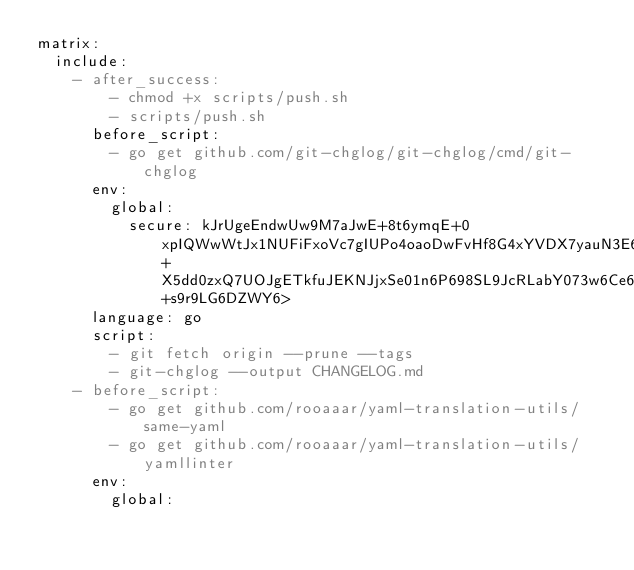<code> <loc_0><loc_0><loc_500><loc_500><_YAML_>matrix:
  include:
    - after_success:
        - chmod +x scripts/push.sh
        - scripts/push.sh
      before_script:
        - go get github.com/git-chglog/git-chglog/cmd/git-chglog
      env:
        global:
          secure: kJrUgeEndwUw9M7aJwE+8t6ymqE+0xpIQWwWtJx1NUFiFxoVc7gIUPo4oaoDwFvHf8G4xYVDX7yauN3E6TDFX7NRjcFqXHB8Up3U66c7os+X5dd0zxQ7UOJgETkfuJEKNJjxSe01n6P698SL9JcRLabY073w6Ce6qCGBpJd7SxzlTCoA0UU6WryM3lwqqXHNTubMAlbaHOMvPR56bIY3+s9r9LG6DZWY6>
      language: go
      script:
        - git fetch origin --prune --tags
        - git-chglog --output CHANGELOG.md
    - before_script:
        - go get github.com/rooaaar/yaml-translation-utils/same-yaml
        - go get github.com/rooaaar/yaml-translation-utils/yamllinter
      env:
        global:</code> 